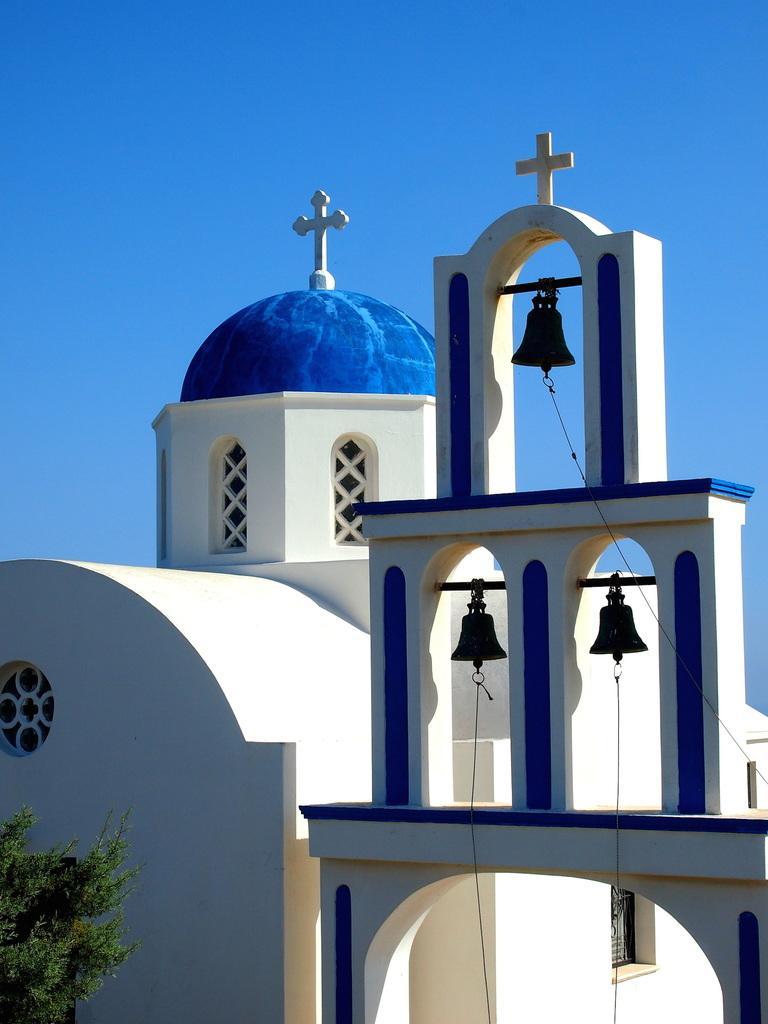Please provide a concise description of this image. In this image we can see a building, bells and cross symbols. In-front of this building there is a tree. Background we can see blue sky. 